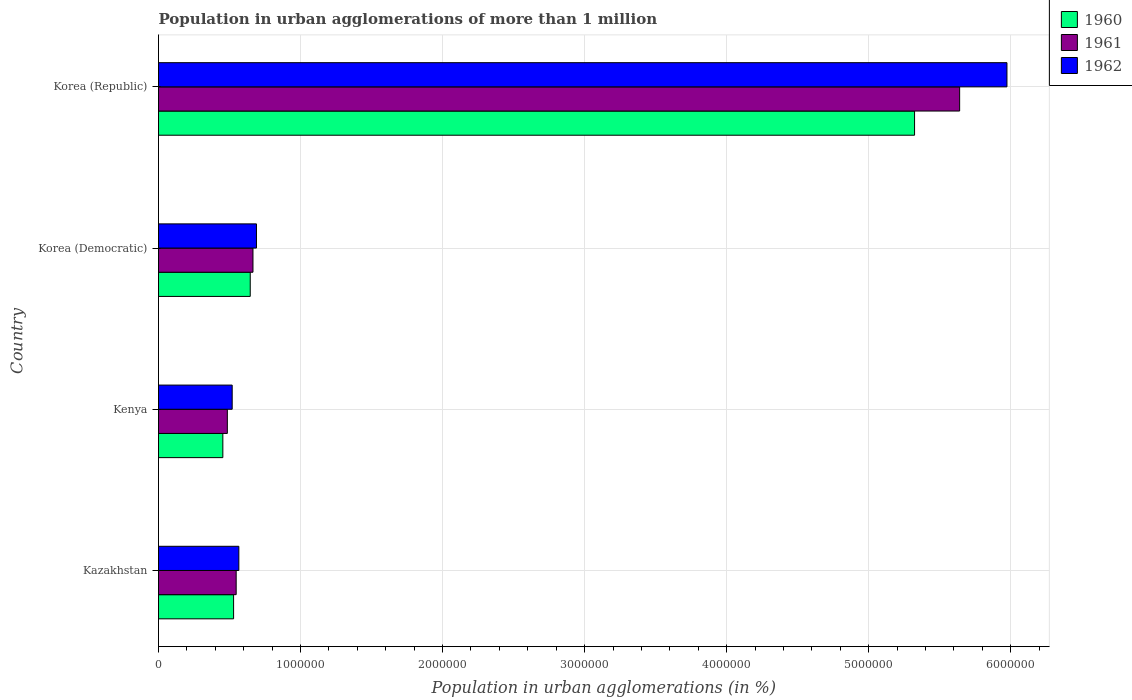How many groups of bars are there?
Offer a terse response. 4. Are the number of bars on each tick of the Y-axis equal?
Your answer should be very brief. Yes. How many bars are there on the 3rd tick from the top?
Provide a succinct answer. 3. How many bars are there on the 3rd tick from the bottom?
Provide a short and direct response. 3. What is the label of the 3rd group of bars from the top?
Ensure brevity in your answer.  Kenya. What is the population in urban agglomerations in 1961 in Korea (Democratic)?
Your answer should be very brief. 6.65e+05. Across all countries, what is the maximum population in urban agglomerations in 1961?
Provide a short and direct response. 5.64e+06. Across all countries, what is the minimum population in urban agglomerations in 1961?
Your answer should be compact. 4.85e+05. In which country was the population in urban agglomerations in 1961 maximum?
Your answer should be compact. Korea (Republic). In which country was the population in urban agglomerations in 1960 minimum?
Offer a terse response. Kenya. What is the total population in urban agglomerations in 1960 in the graph?
Offer a terse response. 6.95e+06. What is the difference between the population in urban agglomerations in 1962 in Kenya and that in Korea (Republic)?
Provide a short and direct response. -5.45e+06. What is the difference between the population in urban agglomerations in 1960 in Kazakhstan and the population in urban agglomerations in 1961 in Kenya?
Your response must be concise. 4.40e+04. What is the average population in urban agglomerations in 1960 per country?
Give a very brief answer. 1.74e+06. What is the difference between the population in urban agglomerations in 1960 and population in urban agglomerations in 1962 in Korea (Republic)?
Your answer should be very brief. -6.50e+05. What is the ratio of the population in urban agglomerations in 1962 in Korea (Democratic) to that in Korea (Republic)?
Keep it short and to the point. 0.12. What is the difference between the highest and the second highest population in urban agglomerations in 1962?
Give a very brief answer. 5.28e+06. What is the difference between the highest and the lowest population in urban agglomerations in 1960?
Provide a succinct answer. 4.87e+06. In how many countries, is the population in urban agglomerations in 1960 greater than the average population in urban agglomerations in 1960 taken over all countries?
Your answer should be very brief. 1. What does the 3rd bar from the top in Kazakhstan represents?
Offer a very short reply. 1960. What does the 3rd bar from the bottom in Korea (Republic) represents?
Your response must be concise. 1962. How many bars are there?
Offer a terse response. 12. Are all the bars in the graph horizontal?
Your response must be concise. Yes. Does the graph contain grids?
Provide a short and direct response. Yes. How many legend labels are there?
Give a very brief answer. 3. What is the title of the graph?
Provide a succinct answer. Population in urban agglomerations of more than 1 million. What is the label or title of the X-axis?
Provide a succinct answer. Population in urban agglomerations (in %). What is the Population in urban agglomerations (in %) in 1960 in Kazakhstan?
Make the answer very short. 5.29e+05. What is the Population in urban agglomerations (in %) of 1961 in Kazakhstan?
Ensure brevity in your answer.  5.47e+05. What is the Population in urban agglomerations (in %) in 1962 in Kazakhstan?
Keep it short and to the point. 5.66e+05. What is the Population in urban agglomerations (in %) in 1960 in Kenya?
Provide a short and direct response. 4.53e+05. What is the Population in urban agglomerations (in %) of 1961 in Kenya?
Ensure brevity in your answer.  4.85e+05. What is the Population in urban agglomerations (in %) of 1962 in Kenya?
Offer a terse response. 5.19e+05. What is the Population in urban agglomerations (in %) of 1960 in Korea (Democratic)?
Offer a terse response. 6.46e+05. What is the Population in urban agglomerations (in %) in 1961 in Korea (Democratic)?
Offer a terse response. 6.65e+05. What is the Population in urban agglomerations (in %) of 1962 in Korea (Democratic)?
Offer a terse response. 6.90e+05. What is the Population in urban agglomerations (in %) in 1960 in Korea (Republic)?
Provide a succinct answer. 5.32e+06. What is the Population in urban agglomerations (in %) of 1961 in Korea (Republic)?
Keep it short and to the point. 5.64e+06. What is the Population in urban agglomerations (in %) in 1962 in Korea (Republic)?
Offer a very short reply. 5.97e+06. Across all countries, what is the maximum Population in urban agglomerations (in %) of 1960?
Make the answer very short. 5.32e+06. Across all countries, what is the maximum Population in urban agglomerations (in %) in 1961?
Offer a terse response. 5.64e+06. Across all countries, what is the maximum Population in urban agglomerations (in %) of 1962?
Keep it short and to the point. 5.97e+06. Across all countries, what is the minimum Population in urban agglomerations (in %) in 1960?
Your answer should be very brief. 4.53e+05. Across all countries, what is the minimum Population in urban agglomerations (in %) in 1961?
Keep it short and to the point. 4.85e+05. Across all countries, what is the minimum Population in urban agglomerations (in %) of 1962?
Provide a succinct answer. 5.19e+05. What is the total Population in urban agglomerations (in %) of 1960 in the graph?
Provide a succinct answer. 6.95e+06. What is the total Population in urban agglomerations (in %) of 1961 in the graph?
Your response must be concise. 7.34e+06. What is the total Population in urban agglomerations (in %) of 1962 in the graph?
Offer a very short reply. 7.75e+06. What is the difference between the Population in urban agglomerations (in %) in 1960 in Kazakhstan and that in Kenya?
Offer a terse response. 7.57e+04. What is the difference between the Population in urban agglomerations (in %) of 1961 in Kazakhstan and that in Kenya?
Provide a succinct answer. 6.22e+04. What is the difference between the Population in urban agglomerations (in %) in 1962 in Kazakhstan and that in Kenya?
Offer a terse response. 4.69e+04. What is the difference between the Population in urban agglomerations (in %) in 1960 in Kazakhstan and that in Korea (Democratic)?
Offer a terse response. -1.17e+05. What is the difference between the Population in urban agglomerations (in %) in 1961 in Kazakhstan and that in Korea (Democratic)?
Provide a short and direct response. -1.18e+05. What is the difference between the Population in urban agglomerations (in %) of 1962 in Kazakhstan and that in Korea (Democratic)?
Offer a terse response. -1.24e+05. What is the difference between the Population in urban agglomerations (in %) of 1960 in Kazakhstan and that in Korea (Republic)?
Offer a very short reply. -4.79e+06. What is the difference between the Population in urban agglomerations (in %) in 1961 in Kazakhstan and that in Korea (Republic)?
Keep it short and to the point. -5.09e+06. What is the difference between the Population in urban agglomerations (in %) of 1962 in Kazakhstan and that in Korea (Republic)?
Keep it short and to the point. -5.41e+06. What is the difference between the Population in urban agglomerations (in %) in 1960 in Kenya and that in Korea (Democratic)?
Your answer should be very brief. -1.93e+05. What is the difference between the Population in urban agglomerations (in %) in 1961 in Kenya and that in Korea (Democratic)?
Ensure brevity in your answer.  -1.80e+05. What is the difference between the Population in urban agglomerations (in %) of 1962 in Kenya and that in Korea (Democratic)?
Offer a very short reply. -1.71e+05. What is the difference between the Population in urban agglomerations (in %) in 1960 in Kenya and that in Korea (Republic)?
Make the answer very short. -4.87e+06. What is the difference between the Population in urban agglomerations (in %) in 1961 in Kenya and that in Korea (Republic)?
Your answer should be compact. -5.16e+06. What is the difference between the Population in urban agglomerations (in %) in 1962 in Kenya and that in Korea (Republic)?
Provide a short and direct response. -5.45e+06. What is the difference between the Population in urban agglomerations (in %) of 1960 in Korea (Democratic) and that in Korea (Republic)?
Keep it short and to the point. -4.68e+06. What is the difference between the Population in urban agglomerations (in %) of 1961 in Korea (Democratic) and that in Korea (Republic)?
Ensure brevity in your answer.  -4.98e+06. What is the difference between the Population in urban agglomerations (in %) in 1962 in Korea (Democratic) and that in Korea (Republic)?
Your answer should be compact. -5.28e+06. What is the difference between the Population in urban agglomerations (in %) in 1960 in Kazakhstan and the Population in urban agglomerations (in %) in 1961 in Kenya?
Keep it short and to the point. 4.40e+04. What is the difference between the Population in urban agglomerations (in %) in 1960 in Kazakhstan and the Population in urban agglomerations (in %) in 1962 in Kenya?
Your answer should be compact. 9944. What is the difference between the Population in urban agglomerations (in %) in 1961 in Kazakhstan and the Population in urban agglomerations (in %) in 1962 in Kenya?
Ensure brevity in your answer.  2.81e+04. What is the difference between the Population in urban agglomerations (in %) in 1960 in Kazakhstan and the Population in urban agglomerations (in %) in 1961 in Korea (Democratic)?
Ensure brevity in your answer.  -1.36e+05. What is the difference between the Population in urban agglomerations (in %) of 1960 in Kazakhstan and the Population in urban agglomerations (in %) of 1962 in Korea (Democratic)?
Give a very brief answer. -1.61e+05. What is the difference between the Population in urban agglomerations (in %) in 1961 in Kazakhstan and the Population in urban agglomerations (in %) in 1962 in Korea (Democratic)?
Ensure brevity in your answer.  -1.43e+05. What is the difference between the Population in urban agglomerations (in %) of 1960 in Kazakhstan and the Population in urban agglomerations (in %) of 1961 in Korea (Republic)?
Keep it short and to the point. -5.11e+06. What is the difference between the Population in urban agglomerations (in %) of 1960 in Kazakhstan and the Population in urban agglomerations (in %) of 1962 in Korea (Republic)?
Keep it short and to the point. -5.44e+06. What is the difference between the Population in urban agglomerations (in %) in 1961 in Kazakhstan and the Population in urban agglomerations (in %) in 1962 in Korea (Republic)?
Provide a short and direct response. -5.43e+06. What is the difference between the Population in urban agglomerations (in %) in 1960 in Kenya and the Population in urban agglomerations (in %) in 1961 in Korea (Democratic)?
Offer a very short reply. -2.12e+05. What is the difference between the Population in urban agglomerations (in %) of 1960 in Kenya and the Population in urban agglomerations (in %) of 1962 in Korea (Democratic)?
Your answer should be compact. -2.37e+05. What is the difference between the Population in urban agglomerations (in %) in 1961 in Kenya and the Population in urban agglomerations (in %) in 1962 in Korea (Democratic)?
Your answer should be very brief. -2.05e+05. What is the difference between the Population in urban agglomerations (in %) of 1960 in Kenya and the Population in urban agglomerations (in %) of 1961 in Korea (Republic)?
Ensure brevity in your answer.  -5.19e+06. What is the difference between the Population in urban agglomerations (in %) in 1960 in Kenya and the Population in urban agglomerations (in %) in 1962 in Korea (Republic)?
Offer a very short reply. -5.52e+06. What is the difference between the Population in urban agglomerations (in %) of 1961 in Kenya and the Population in urban agglomerations (in %) of 1962 in Korea (Republic)?
Give a very brief answer. -5.49e+06. What is the difference between the Population in urban agglomerations (in %) in 1960 in Korea (Democratic) and the Population in urban agglomerations (in %) in 1961 in Korea (Republic)?
Provide a succinct answer. -4.99e+06. What is the difference between the Population in urban agglomerations (in %) of 1960 in Korea (Democratic) and the Population in urban agglomerations (in %) of 1962 in Korea (Republic)?
Your answer should be very brief. -5.33e+06. What is the difference between the Population in urban agglomerations (in %) of 1961 in Korea (Democratic) and the Population in urban agglomerations (in %) of 1962 in Korea (Republic)?
Offer a very short reply. -5.31e+06. What is the average Population in urban agglomerations (in %) in 1960 per country?
Offer a terse response. 1.74e+06. What is the average Population in urban agglomerations (in %) in 1961 per country?
Your answer should be compact. 1.83e+06. What is the average Population in urban agglomerations (in %) in 1962 per country?
Your answer should be compact. 1.94e+06. What is the difference between the Population in urban agglomerations (in %) in 1960 and Population in urban agglomerations (in %) in 1961 in Kazakhstan?
Make the answer very short. -1.82e+04. What is the difference between the Population in urban agglomerations (in %) in 1960 and Population in urban agglomerations (in %) in 1962 in Kazakhstan?
Provide a succinct answer. -3.70e+04. What is the difference between the Population in urban agglomerations (in %) of 1961 and Population in urban agglomerations (in %) of 1962 in Kazakhstan?
Your answer should be compact. -1.88e+04. What is the difference between the Population in urban agglomerations (in %) in 1960 and Population in urban agglomerations (in %) in 1961 in Kenya?
Your response must be concise. -3.17e+04. What is the difference between the Population in urban agglomerations (in %) in 1960 and Population in urban agglomerations (in %) in 1962 in Kenya?
Your answer should be very brief. -6.58e+04. What is the difference between the Population in urban agglomerations (in %) of 1961 and Population in urban agglomerations (in %) of 1962 in Kenya?
Provide a succinct answer. -3.41e+04. What is the difference between the Population in urban agglomerations (in %) of 1960 and Population in urban agglomerations (in %) of 1961 in Korea (Democratic)?
Your answer should be compact. -1.92e+04. What is the difference between the Population in urban agglomerations (in %) in 1960 and Population in urban agglomerations (in %) in 1962 in Korea (Democratic)?
Provide a short and direct response. -4.39e+04. What is the difference between the Population in urban agglomerations (in %) of 1961 and Population in urban agglomerations (in %) of 1962 in Korea (Democratic)?
Keep it short and to the point. -2.46e+04. What is the difference between the Population in urban agglomerations (in %) in 1960 and Population in urban agglomerations (in %) in 1961 in Korea (Republic)?
Offer a very short reply. -3.17e+05. What is the difference between the Population in urban agglomerations (in %) of 1960 and Population in urban agglomerations (in %) of 1962 in Korea (Republic)?
Ensure brevity in your answer.  -6.50e+05. What is the difference between the Population in urban agglomerations (in %) in 1961 and Population in urban agglomerations (in %) in 1962 in Korea (Republic)?
Give a very brief answer. -3.33e+05. What is the ratio of the Population in urban agglomerations (in %) of 1960 in Kazakhstan to that in Kenya?
Your answer should be very brief. 1.17. What is the ratio of the Population in urban agglomerations (in %) in 1961 in Kazakhstan to that in Kenya?
Provide a short and direct response. 1.13. What is the ratio of the Population in urban agglomerations (in %) in 1962 in Kazakhstan to that in Kenya?
Your answer should be compact. 1.09. What is the ratio of the Population in urban agglomerations (in %) in 1960 in Kazakhstan to that in Korea (Democratic)?
Your response must be concise. 0.82. What is the ratio of the Population in urban agglomerations (in %) of 1961 in Kazakhstan to that in Korea (Democratic)?
Provide a succinct answer. 0.82. What is the ratio of the Population in urban agglomerations (in %) in 1962 in Kazakhstan to that in Korea (Democratic)?
Keep it short and to the point. 0.82. What is the ratio of the Population in urban agglomerations (in %) in 1960 in Kazakhstan to that in Korea (Republic)?
Keep it short and to the point. 0.1. What is the ratio of the Population in urban agglomerations (in %) of 1961 in Kazakhstan to that in Korea (Republic)?
Offer a very short reply. 0.1. What is the ratio of the Population in urban agglomerations (in %) in 1962 in Kazakhstan to that in Korea (Republic)?
Offer a very short reply. 0.09. What is the ratio of the Population in urban agglomerations (in %) in 1960 in Kenya to that in Korea (Democratic)?
Your answer should be very brief. 0.7. What is the ratio of the Population in urban agglomerations (in %) of 1961 in Kenya to that in Korea (Democratic)?
Keep it short and to the point. 0.73. What is the ratio of the Population in urban agglomerations (in %) in 1962 in Kenya to that in Korea (Democratic)?
Give a very brief answer. 0.75. What is the ratio of the Population in urban agglomerations (in %) in 1960 in Kenya to that in Korea (Republic)?
Provide a short and direct response. 0.09. What is the ratio of the Population in urban agglomerations (in %) of 1961 in Kenya to that in Korea (Republic)?
Make the answer very short. 0.09. What is the ratio of the Population in urban agglomerations (in %) of 1962 in Kenya to that in Korea (Republic)?
Offer a very short reply. 0.09. What is the ratio of the Population in urban agglomerations (in %) in 1960 in Korea (Democratic) to that in Korea (Republic)?
Ensure brevity in your answer.  0.12. What is the ratio of the Population in urban agglomerations (in %) in 1961 in Korea (Democratic) to that in Korea (Republic)?
Offer a terse response. 0.12. What is the ratio of the Population in urban agglomerations (in %) of 1962 in Korea (Democratic) to that in Korea (Republic)?
Keep it short and to the point. 0.12. What is the difference between the highest and the second highest Population in urban agglomerations (in %) in 1960?
Provide a succinct answer. 4.68e+06. What is the difference between the highest and the second highest Population in urban agglomerations (in %) of 1961?
Ensure brevity in your answer.  4.98e+06. What is the difference between the highest and the second highest Population in urban agglomerations (in %) in 1962?
Your answer should be compact. 5.28e+06. What is the difference between the highest and the lowest Population in urban agglomerations (in %) of 1960?
Keep it short and to the point. 4.87e+06. What is the difference between the highest and the lowest Population in urban agglomerations (in %) of 1961?
Provide a succinct answer. 5.16e+06. What is the difference between the highest and the lowest Population in urban agglomerations (in %) of 1962?
Make the answer very short. 5.45e+06. 